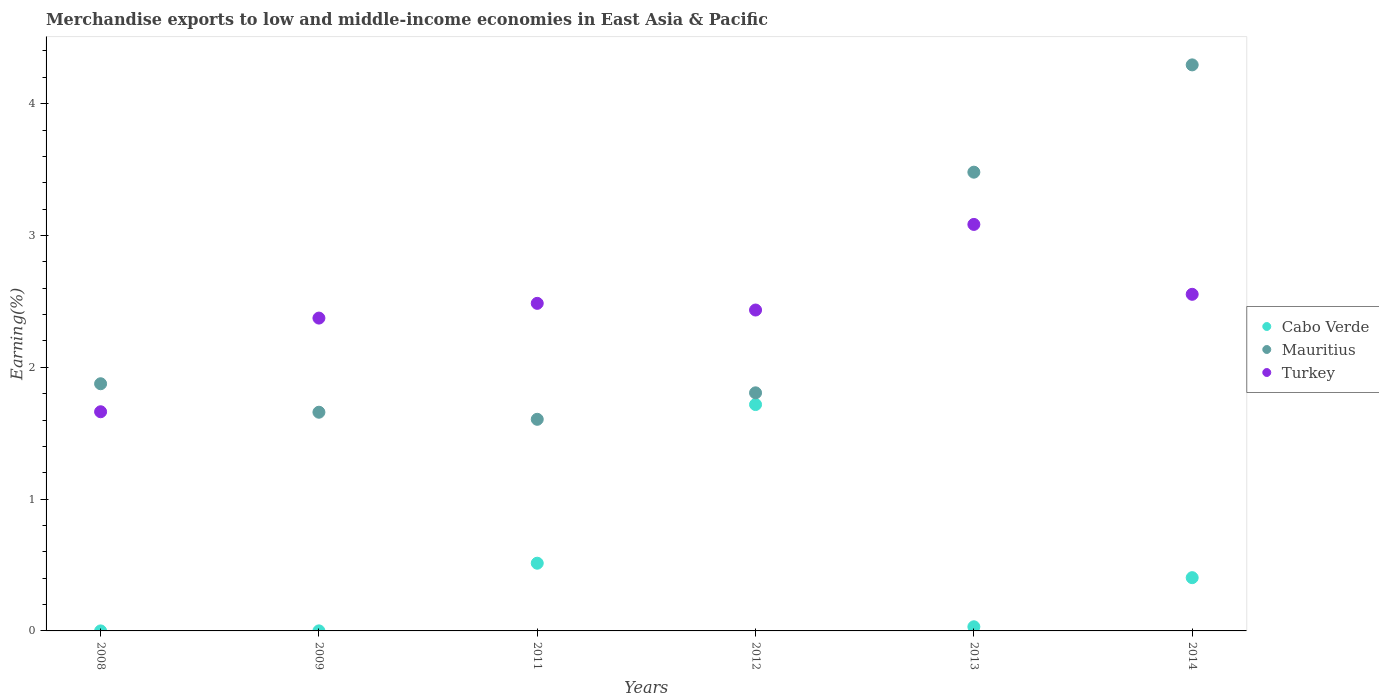Is the number of dotlines equal to the number of legend labels?
Give a very brief answer. Yes. What is the percentage of amount earned from merchandise exports in Cabo Verde in 2011?
Make the answer very short. 0.51. Across all years, what is the maximum percentage of amount earned from merchandise exports in Turkey?
Ensure brevity in your answer.  3.08. Across all years, what is the minimum percentage of amount earned from merchandise exports in Mauritius?
Offer a terse response. 1.61. In which year was the percentage of amount earned from merchandise exports in Cabo Verde maximum?
Keep it short and to the point. 2012. In which year was the percentage of amount earned from merchandise exports in Cabo Verde minimum?
Keep it short and to the point. 2008. What is the total percentage of amount earned from merchandise exports in Cabo Verde in the graph?
Offer a very short reply. 2.67. What is the difference between the percentage of amount earned from merchandise exports in Turkey in 2008 and that in 2013?
Offer a terse response. -1.42. What is the difference between the percentage of amount earned from merchandise exports in Cabo Verde in 2014 and the percentage of amount earned from merchandise exports in Mauritius in 2009?
Ensure brevity in your answer.  -1.26. What is the average percentage of amount earned from merchandise exports in Mauritius per year?
Your response must be concise. 2.45. In the year 2012, what is the difference between the percentage of amount earned from merchandise exports in Turkey and percentage of amount earned from merchandise exports in Cabo Verde?
Your answer should be very brief. 0.72. In how many years, is the percentage of amount earned from merchandise exports in Mauritius greater than 2.6 %?
Ensure brevity in your answer.  2. What is the ratio of the percentage of amount earned from merchandise exports in Turkey in 2011 to that in 2013?
Your answer should be compact. 0.81. What is the difference between the highest and the second highest percentage of amount earned from merchandise exports in Mauritius?
Your response must be concise. 0.81. What is the difference between the highest and the lowest percentage of amount earned from merchandise exports in Mauritius?
Your response must be concise. 2.69. Is the sum of the percentage of amount earned from merchandise exports in Mauritius in 2008 and 2012 greater than the maximum percentage of amount earned from merchandise exports in Cabo Verde across all years?
Your answer should be very brief. Yes. How many years are there in the graph?
Your answer should be very brief. 6. What is the difference between two consecutive major ticks on the Y-axis?
Your response must be concise. 1. Where does the legend appear in the graph?
Ensure brevity in your answer.  Center right. How many legend labels are there?
Your answer should be very brief. 3. What is the title of the graph?
Offer a terse response. Merchandise exports to low and middle-income economies in East Asia & Pacific. Does "Turkmenistan" appear as one of the legend labels in the graph?
Make the answer very short. No. What is the label or title of the Y-axis?
Offer a very short reply. Earning(%). What is the Earning(%) in Cabo Verde in 2008?
Offer a terse response. 6.60673795000463e-5. What is the Earning(%) of Mauritius in 2008?
Give a very brief answer. 1.88. What is the Earning(%) in Turkey in 2008?
Keep it short and to the point. 1.66. What is the Earning(%) in Cabo Verde in 2009?
Provide a short and direct response. 0. What is the Earning(%) in Mauritius in 2009?
Keep it short and to the point. 1.66. What is the Earning(%) in Turkey in 2009?
Your answer should be compact. 2.37. What is the Earning(%) of Cabo Verde in 2011?
Offer a terse response. 0.51. What is the Earning(%) of Mauritius in 2011?
Your response must be concise. 1.61. What is the Earning(%) in Turkey in 2011?
Your response must be concise. 2.49. What is the Earning(%) in Cabo Verde in 2012?
Ensure brevity in your answer.  1.72. What is the Earning(%) in Mauritius in 2012?
Offer a terse response. 1.81. What is the Earning(%) in Turkey in 2012?
Make the answer very short. 2.43. What is the Earning(%) of Cabo Verde in 2013?
Give a very brief answer. 0.03. What is the Earning(%) of Mauritius in 2013?
Offer a terse response. 3.48. What is the Earning(%) in Turkey in 2013?
Your answer should be compact. 3.08. What is the Earning(%) of Cabo Verde in 2014?
Ensure brevity in your answer.  0.4. What is the Earning(%) of Mauritius in 2014?
Provide a short and direct response. 4.29. What is the Earning(%) in Turkey in 2014?
Provide a succinct answer. 2.55. Across all years, what is the maximum Earning(%) in Cabo Verde?
Your response must be concise. 1.72. Across all years, what is the maximum Earning(%) in Mauritius?
Your answer should be compact. 4.29. Across all years, what is the maximum Earning(%) of Turkey?
Ensure brevity in your answer.  3.08. Across all years, what is the minimum Earning(%) of Cabo Verde?
Offer a very short reply. 6.60673795000463e-5. Across all years, what is the minimum Earning(%) of Mauritius?
Offer a very short reply. 1.61. Across all years, what is the minimum Earning(%) in Turkey?
Provide a succinct answer. 1.66. What is the total Earning(%) in Cabo Verde in the graph?
Keep it short and to the point. 2.67. What is the total Earning(%) in Mauritius in the graph?
Give a very brief answer. 14.72. What is the total Earning(%) of Turkey in the graph?
Offer a terse response. 14.59. What is the difference between the Earning(%) in Cabo Verde in 2008 and that in 2009?
Offer a very short reply. -0. What is the difference between the Earning(%) in Mauritius in 2008 and that in 2009?
Offer a terse response. 0.22. What is the difference between the Earning(%) of Turkey in 2008 and that in 2009?
Ensure brevity in your answer.  -0.71. What is the difference between the Earning(%) of Cabo Verde in 2008 and that in 2011?
Provide a short and direct response. -0.51. What is the difference between the Earning(%) in Mauritius in 2008 and that in 2011?
Offer a very short reply. 0.27. What is the difference between the Earning(%) in Turkey in 2008 and that in 2011?
Offer a very short reply. -0.82. What is the difference between the Earning(%) in Cabo Verde in 2008 and that in 2012?
Give a very brief answer. -1.72. What is the difference between the Earning(%) in Mauritius in 2008 and that in 2012?
Provide a short and direct response. 0.07. What is the difference between the Earning(%) of Turkey in 2008 and that in 2012?
Your answer should be very brief. -0.77. What is the difference between the Earning(%) in Cabo Verde in 2008 and that in 2013?
Your answer should be compact. -0.03. What is the difference between the Earning(%) of Mauritius in 2008 and that in 2013?
Give a very brief answer. -1.6. What is the difference between the Earning(%) in Turkey in 2008 and that in 2013?
Your answer should be compact. -1.42. What is the difference between the Earning(%) in Cabo Verde in 2008 and that in 2014?
Provide a short and direct response. -0.4. What is the difference between the Earning(%) in Mauritius in 2008 and that in 2014?
Your answer should be very brief. -2.42. What is the difference between the Earning(%) in Turkey in 2008 and that in 2014?
Provide a short and direct response. -0.89. What is the difference between the Earning(%) of Cabo Verde in 2009 and that in 2011?
Offer a very short reply. -0.51. What is the difference between the Earning(%) in Mauritius in 2009 and that in 2011?
Offer a terse response. 0.05. What is the difference between the Earning(%) of Turkey in 2009 and that in 2011?
Offer a very short reply. -0.11. What is the difference between the Earning(%) in Cabo Verde in 2009 and that in 2012?
Ensure brevity in your answer.  -1.72. What is the difference between the Earning(%) in Mauritius in 2009 and that in 2012?
Offer a terse response. -0.15. What is the difference between the Earning(%) of Turkey in 2009 and that in 2012?
Offer a very short reply. -0.06. What is the difference between the Earning(%) in Cabo Verde in 2009 and that in 2013?
Your answer should be very brief. -0.03. What is the difference between the Earning(%) of Mauritius in 2009 and that in 2013?
Provide a short and direct response. -1.82. What is the difference between the Earning(%) of Turkey in 2009 and that in 2013?
Provide a short and direct response. -0.71. What is the difference between the Earning(%) of Cabo Verde in 2009 and that in 2014?
Ensure brevity in your answer.  -0.4. What is the difference between the Earning(%) in Mauritius in 2009 and that in 2014?
Make the answer very short. -2.64. What is the difference between the Earning(%) in Turkey in 2009 and that in 2014?
Make the answer very short. -0.18. What is the difference between the Earning(%) in Cabo Verde in 2011 and that in 2012?
Offer a terse response. -1.2. What is the difference between the Earning(%) in Mauritius in 2011 and that in 2012?
Ensure brevity in your answer.  -0.2. What is the difference between the Earning(%) of Turkey in 2011 and that in 2012?
Ensure brevity in your answer.  0.05. What is the difference between the Earning(%) of Cabo Verde in 2011 and that in 2013?
Provide a short and direct response. 0.48. What is the difference between the Earning(%) in Mauritius in 2011 and that in 2013?
Your answer should be very brief. -1.87. What is the difference between the Earning(%) of Turkey in 2011 and that in 2013?
Your answer should be very brief. -0.6. What is the difference between the Earning(%) of Cabo Verde in 2011 and that in 2014?
Provide a short and direct response. 0.11. What is the difference between the Earning(%) in Mauritius in 2011 and that in 2014?
Ensure brevity in your answer.  -2.69. What is the difference between the Earning(%) of Turkey in 2011 and that in 2014?
Your response must be concise. -0.07. What is the difference between the Earning(%) in Cabo Verde in 2012 and that in 2013?
Your response must be concise. 1.69. What is the difference between the Earning(%) of Mauritius in 2012 and that in 2013?
Your response must be concise. -1.67. What is the difference between the Earning(%) in Turkey in 2012 and that in 2013?
Make the answer very short. -0.65. What is the difference between the Earning(%) of Cabo Verde in 2012 and that in 2014?
Provide a short and direct response. 1.31. What is the difference between the Earning(%) in Mauritius in 2012 and that in 2014?
Provide a succinct answer. -2.49. What is the difference between the Earning(%) of Turkey in 2012 and that in 2014?
Provide a succinct answer. -0.12. What is the difference between the Earning(%) of Cabo Verde in 2013 and that in 2014?
Provide a short and direct response. -0.37. What is the difference between the Earning(%) in Mauritius in 2013 and that in 2014?
Provide a short and direct response. -0.81. What is the difference between the Earning(%) of Turkey in 2013 and that in 2014?
Keep it short and to the point. 0.53. What is the difference between the Earning(%) of Cabo Verde in 2008 and the Earning(%) of Mauritius in 2009?
Provide a short and direct response. -1.66. What is the difference between the Earning(%) of Cabo Verde in 2008 and the Earning(%) of Turkey in 2009?
Your response must be concise. -2.37. What is the difference between the Earning(%) in Mauritius in 2008 and the Earning(%) in Turkey in 2009?
Make the answer very short. -0.5. What is the difference between the Earning(%) of Cabo Verde in 2008 and the Earning(%) of Mauritius in 2011?
Give a very brief answer. -1.61. What is the difference between the Earning(%) in Cabo Verde in 2008 and the Earning(%) in Turkey in 2011?
Your answer should be very brief. -2.48. What is the difference between the Earning(%) of Mauritius in 2008 and the Earning(%) of Turkey in 2011?
Provide a succinct answer. -0.61. What is the difference between the Earning(%) in Cabo Verde in 2008 and the Earning(%) in Mauritius in 2012?
Offer a terse response. -1.81. What is the difference between the Earning(%) of Cabo Verde in 2008 and the Earning(%) of Turkey in 2012?
Keep it short and to the point. -2.43. What is the difference between the Earning(%) in Mauritius in 2008 and the Earning(%) in Turkey in 2012?
Your response must be concise. -0.56. What is the difference between the Earning(%) of Cabo Verde in 2008 and the Earning(%) of Mauritius in 2013?
Give a very brief answer. -3.48. What is the difference between the Earning(%) of Cabo Verde in 2008 and the Earning(%) of Turkey in 2013?
Make the answer very short. -3.08. What is the difference between the Earning(%) of Mauritius in 2008 and the Earning(%) of Turkey in 2013?
Provide a succinct answer. -1.21. What is the difference between the Earning(%) of Cabo Verde in 2008 and the Earning(%) of Mauritius in 2014?
Keep it short and to the point. -4.29. What is the difference between the Earning(%) in Cabo Verde in 2008 and the Earning(%) in Turkey in 2014?
Your answer should be compact. -2.55. What is the difference between the Earning(%) of Mauritius in 2008 and the Earning(%) of Turkey in 2014?
Offer a very short reply. -0.68. What is the difference between the Earning(%) in Cabo Verde in 2009 and the Earning(%) in Mauritius in 2011?
Offer a very short reply. -1.6. What is the difference between the Earning(%) in Cabo Verde in 2009 and the Earning(%) in Turkey in 2011?
Offer a terse response. -2.48. What is the difference between the Earning(%) in Mauritius in 2009 and the Earning(%) in Turkey in 2011?
Provide a short and direct response. -0.83. What is the difference between the Earning(%) of Cabo Verde in 2009 and the Earning(%) of Mauritius in 2012?
Give a very brief answer. -1.81. What is the difference between the Earning(%) in Cabo Verde in 2009 and the Earning(%) in Turkey in 2012?
Provide a succinct answer. -2.43. What is the difference between the Earning(%) of Mauritius in 2009 and the Earning(%) of Turkey in 2012?
Offer a very short reply. -0.78. What is the difference between the Earning(%) in Cabo Verde in 2009 and the Earning(%) in Mauritius in 2013?
Provide a short and direct response. -3.48. What is the difference between the Earning(%) in Cabo Verde in 2009 and the Earning(%) in Turkey in 2013?
Keep it short and to the point. -3.08. What is the difference between the Earning(%) in Mauritius in 2009 and the Earning(%) in Turkey in 2013?
Make the answer very short. -1.42. What is the difference between the Earning(%) of Cabo Verde in 2009 and the Earning(%) of Mauritius in 2014?
Give a very brief answer. -4.29. What is the difference between the Earning(%) in Cabo Verde in 2009 and the Earning(%) in Turkey in 2014?
Offer a very short reply. -2.55. What is the difference between the Earning(%) of Mauritius in 2009 and the Earning(%) of Turkey in 2014?
Offer a very short reply. -0.89. What is the difference between the Earning(%) of Cabo Verde in 2011 and the Earning(%) of Mauritius in 2012?
Make the answer very short. -1.29. What is the difference between the Earning(%) of Cabo Verde in 2011 and the Earning(%) of Turkey in 2012?
Offer a very short reply. -1.92. What is the difference between the Earning(%) in Mauritius in 2011 and the Earning(%) in Turkey in 2012?
Your answer should be compact. -0.83. What is the difference between the Earning(%) of Cabo Verde in 2011 and the Earning(%) of Mauritius in 2013?
Your answer should be very brief. -2.97. What is the difference between the Earning(%) of Cabo Verde in 2011 and the Earning(%) of Turkey in 2013?
Provide a short and direct response. -2.57. What is the difference between the Earning(%) of Mauritius in 2011 and the Earning(%) of Turkey in 2013?
Provide a short and direct response. -1.48. What is the difference between the Earning(%) in Cabo Verde in 2011 and the Earning(%) in Mauritius in 2014?
Provide a succinct answer. -3.78. What is the difference between the Earning(%) in Cabo Verde in 2011 and the Earning(%) in Turkey in 2014?
Keep it short and to the point. -2.04. What is the difference between the Earning(%) of Mauritius in 2011 and the Earning(%) of Turkey in 2014?
Offer a very short reply. -0.95. What is the difference between the Earning(%) of Cabo Verde in 2012 and the Earning(%) of Mauritius in 2013?
Provide a short and direct response. -1.76. What is the difference between the Earning(%) of Cabo Verde in 2012 and the Earning(%) of Turkey in 2013?
Offer a terse response. -1.37. What is the difference between the Earning(%) in Mauritius in 2012 and the Earning(%) in Turkey in 2013?
Ensure brevity in your answer.  -1.28. What is the difference between the Earning(%) of Cabo Verde in 2012 and the Earning(%) of Mauritius in 2014?
Offer a terse response. -2.58. What is the difference between the Earning(%) of Cabo Verde in 2012 and the Earning(%) of Turkey in 2014?
Ensure brevity in your answer.  -0.84. What is the difference between the Earning(%) in Mauritius in 2012 and the Earning(%) in Turkey in 2014?
Your answer should be compact. -0.75. What is the difference between the Earning(%) in Cabo Verde in 2013 and the Earning(%) in Mauritius in 2014?
Offer a very short reply. -4.26. What is the difference between the Earning(%) of Cabo Verde in 2013 and the Earning(%) of Turkey in 2014?
Your answer should be very brief. -2.52. What is the difference between the Earning(%) of Mauritius in 2013 and the Earning(%) of Turkey in 2014?
Provide a short and direct response. 0.93. What is the average Earning(%) of Cabo Verde per year?
Your response must be concise. 0.44. What is the average Earning(%) of Mauritius per year?
Your answer should be very brief. 2.45. What is the average Earning(%) in Turkey per year?
Offer a very short reply. 2.43. In the year 2008, what is the difference between the Earning(%) of Cabo Verde and Earning(%) of Mauritius?
Keep it short and to the point. -1.88. In the year 2008, what is the difference between the Earning(%) in Cabo Verde and Earning(%) in Turkey?
Offer a very short reply. -1.66. In the year 2008, what is the difference between the Earning(%) in Mauritius and Earning(%) in Turkey?
Provide a succinct answer. 0.21. In the year 2009, what is the difference between the Earning(%) in Cabo Verde and Earning(%) in Mauritius?
Give a very brief answer. -1.66. In the year 2009, what is the difference between the Earning(%) of Cabo Verde and Earning(%) of Turkey?
Your answer should be very brief. -2.37. In the year 2009, what is the difference between the Earning(%) in Mauritius and Earning(%) in Turkey?
Your answer should be very brief. -0.71. In the year 2011, what is the difference between the Earning(%) of Cabo Verde and Earning(%) of Mauritius?
Your response must be concise. -1.09. In the year 2011, what is the difference between the Earning(%) in Cabo Verde and Earning(%) in Turkey?
Give a very brief answer. -1.97. In the year 2011, what is the difference between the Earning(%) in Mauritius and Earning(%) in Turkey?
Your answer should be compact. -0.88. In the year 2012, what is the difference between the Earning(%) in Cabo Verde and Earning(%) in Mauritius?
Your answer should be very brief. -0.09. In the year 2012, what is the difference between the Earning(%) in Cabo Verde and Earning(%) in Turkey?
Keep it short and to the point. -0.72. In the year 2012, what is the difference between the Earning(%) of Mauritius and Earning(%) of Turkey?
Offer a terse response. -0.63. In the year 2013, what is the difference between the Earning(%) in Cabo Verde and Earning(%) in Mauritius?
Keep it short and to the point. -3.45. In the year 2013, what is the difference between the Earning(%) of Cabo Verde and Earning(%) of Turkey?
Make the answer very short. -3.05. In the year 2013, what is the difference between the Earning(%) in Mauritius and Earning(%) in Turkey?
Your response must be concise. 0.4. In the year 2014, what is the difference between the Earning(%) in Cabo Verde and Earning(%) in Mauritius?
Give a very brief answer. -3.89. In the year 2014, what is the difference between the Earning(%) of Cabo Verde and Earning(%) of Turkey?
Provide a succinct answer. -2.15. In the year 2014, what is the difference between the Earning(%) in Mauritius and Earning(%) in Turkey?
Give a very brief answer. 1.74. What is the ratio of the Earning(%) of Cabo Verde in 2008 to that in 2009?
Your response must be concise. 0.18. What is the ratio of the Earning(%) in Mauritius in 2008 to that in 2009?
Give a very brief answer. 1.13. What is the ratio of the Earning(%) in Turkey in 2008 to that in 2009?
Your response must be concise. 0.7. What is the ratio of the Earning(%) of Mauritius in 2008 to that in 2011?
Offer a very short reply. 1.17. What is the ratio of the Earning(%) in Turkey in 2008 to that in 2011?
Keep it short and to the point. 0.67. What is the ratio of the Earning(%) in Cabo Verde in 2008 to that in 2012?
Provide a succinct answer. 0. What is the ratio of the Earning(%) of Mauritius in 2008 to that in 2012?
Your answer should be very brief. 1.04. What is the ratio of the Earning(%) in Turkey in 2008 to that in 2012?
Provide a succinct answer. 0.68. What is the ratio of the Earning(%) of Cabo Verde in 2008 to that in 2013?
Provide a short and direct response. 0. What is the ratio of the Earning(%) of Mauritius in 2008 to that in 2013?
Offer a very short reply. 0.54. What is the ratio of the Earning(%) of Turkey in 2008 to that in 2013?
Offer a terse response. 0.54. What is the ratio of the Earning(%) of Cabo Verde in 2008 to that in 2014?
Offer a terse response. 0. What is the ratio of the Earning(%) in Mauritius in 2008 to that in 2014?
Provide a short and direct response. 0.44. What is the ratio of the Earning(%) of Turkey in 2008 to that in 2014?
Your answer should be compact. 0.65. What is the ratio of the Earning(%) of Cabo Verde in 2009 to that in 2011?
Offer a very short reply. 0. What is the ratio of the Earning(%) of Mauritius in 2009 to that in 2011?
Keep it short and to the point. 1.03. What is the ratio of the Earning(%) of Turkey in 2009 to that in 2011?
Provide a short and direct response. 0.95. What is the ratio of the Earning(%) in Cabo Verde in 2009 to that in 2012?
Offer a terse response. 0. What is the ratio of the Earning(%) in Mauritius in 2009 to that in 2012?
Offer a very short reply. 0.92. What is the ratio of the Earning(%) in Turkey in 2009 to that in 2012?
Provide a succinct answer. 0.97. What is the ratio of the Earning(%) of Cabo Verde in 2009 to that in 2013?
Your answer should be compact. 0.01. What is the ratio of the Earning(%) in Mauritius in 2009 to that in 2013?
Ensure brevity in your answer.  0.48. What is the ratio of the Earning(%) of Turkey in 2009 to that in 2013?
Offer a terse response. 0.77. What is the ratio of the Earning(%) of Cabo Verde in 2009 to that in 2014?
Offer a terse response. 0. What is the ratio of the Earning(%) of Mauritius in 2009 to that in 2014?
Ensure brevity in your answer.  0.39. What is the ratio of the Earning(%) in Turkey in 2009 to that in 2014?
Ensure brevity in your answer.  0.93. What is the ratio of the Earning(%) in Cabo Verde in 2011 to that in 2012?
Your answer should be very brief. 0.3. What is the ratio of the Earning(%) of Mauritius in 2011 to that in 2012?
Your response must be concise. 0.89. What is the ratio of the Earning(%) of Turkey in 2011 to that in 2012?
Make the answer very short. 1.02. What is the ratio of the Earning(%) in Cabo Verde in 2011 to that in 2013?
Your answer should be compact. 16.35. What is the ratio of the Earning(%) of Mauritius in 2011 to that in 2013?
Ensure brevity in your answer.  0.46. What is the ratio of the Earning(%) in Turkey in 2011 to that in 2013?
Your answer should be compact. 0.81. What is the ratio of the Earning(%) of Cabo Verde in 2011 to that in 2014?
Provide a short and direct response. 1.27. What is the ratio of the Earning(%) in Mauritius in 2011 to that in 2014?
Provide a succinct answer. 0.37. What is the ratio of the Earning(%) of Turkey in 2011 to that in 2014?
Provide a succinct answer. 0.97. What is the ratio of the Earning(%) in Cabo Verde in 2012 to that in 2013?
Provide a short and direct response. 54.65. What is the ratio of the Earning(%) in Mauritius in 2012 to that in 2013?
Your response must be concise. 0.52. What is the ratio of the Earning(%) in Turkey in 2012 to that in 2013?
Your response must be concise. 0.79. What is the ratio of the Earning(%) in Cabo Verde in 2012 to that in 2014?
Your answer should be compact. 4.25. What is the ratio of the Earning(%) in Mauritius in 2012 to that in 2014?
Ensure brevity in your answer.  0.42. What is the ratio of the Earning(%) of Turkey in 2012 to that in 2014?
Provide a succinct answer. 0.95. What is the ratio of the Earning(%) in Cabo Verde in 2013 to that in 2014?
Provide a succinct answer. 0.08. What is the ratio of the Earning(%) of Mauritius in 2013 to that in 2014?
Offer a terse response. 0.81. What is the ratio of the Earning(%) of Turkey in 2013 to that in 2014?
Offer a terse response. 1.21. What is the difference between the highest and the second highest Earning(%) of Cabo Verde?
Provide a short and direct response. 1.2. What is the difference between the highest and the second highest Earning(%) of Mauritius?
Offer a terse response. 0.81. What is the difference between the highest and the second highest Earning(%) of Turkey?
Your answer should be compact. 0.53. What is the difference between the highest and the lowest Earning(%) in Cabo Verde?
Your answer should be very brief. 1.72. What is the difference between the highest and the lowest Earning(%) in Mauritius?
Give a very brief answer. 2.69. What is the difference between the highest and the lowest Earning(%) of Turkey?
Make the answer very short. 1.42. 